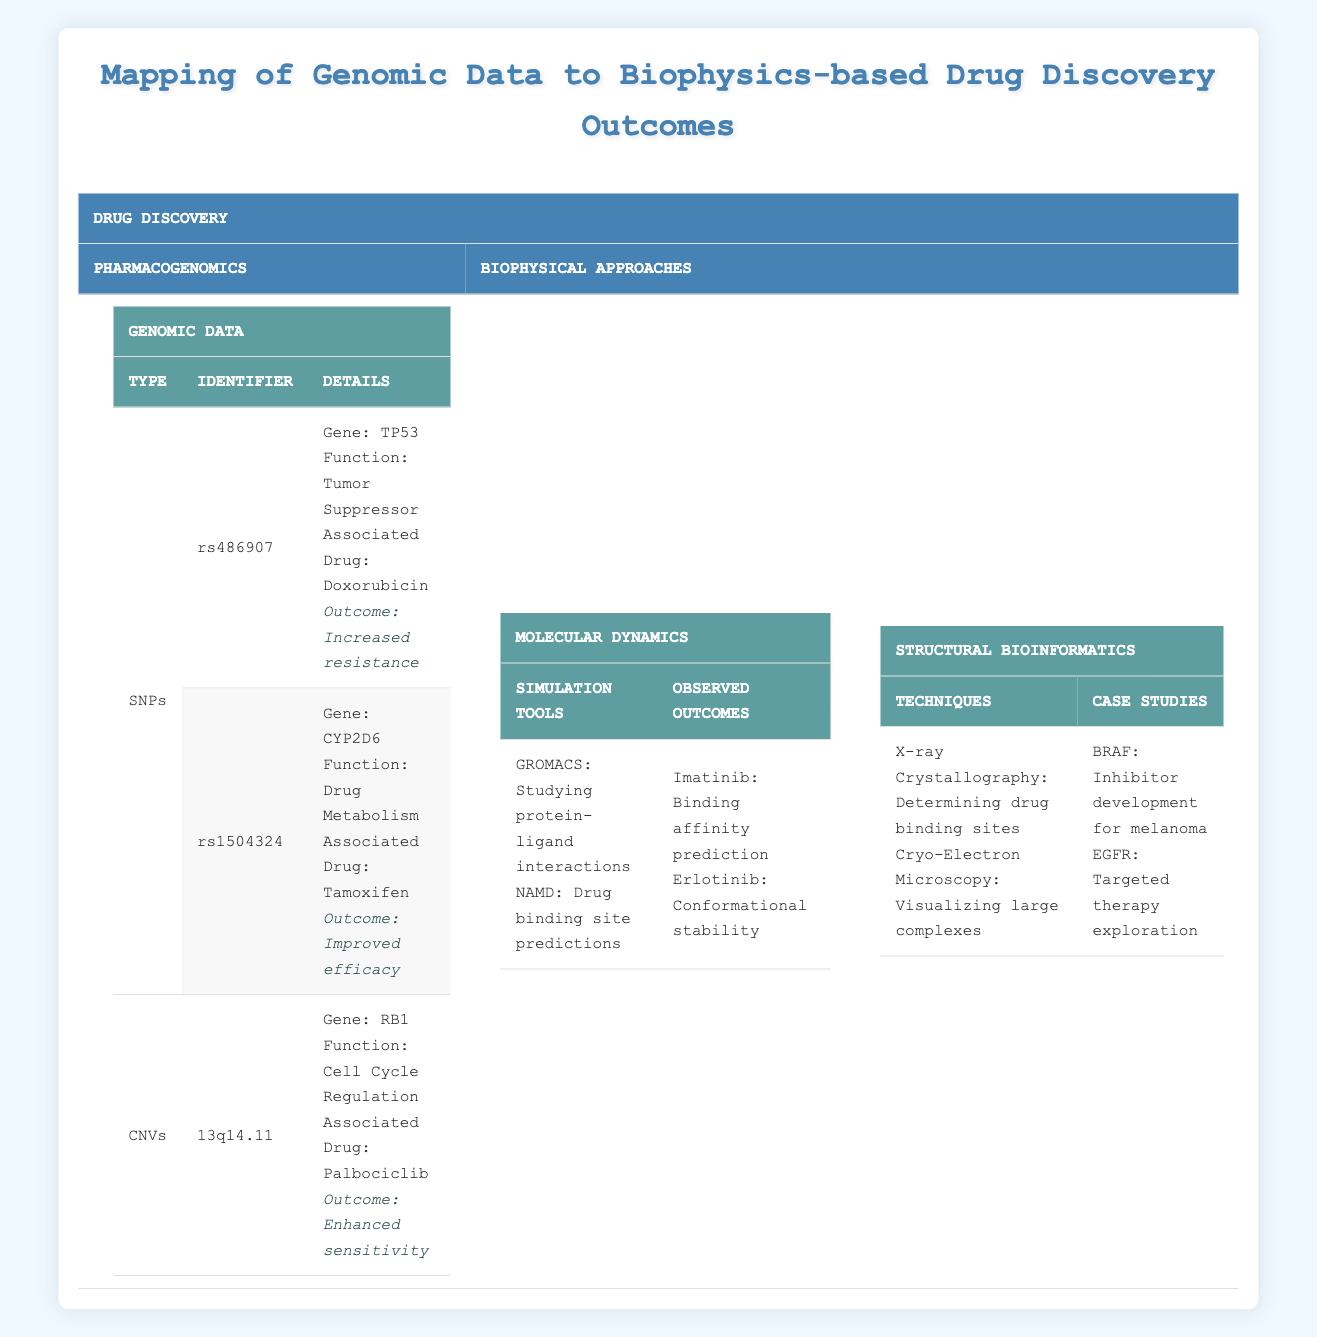What gene is associated with the SNP rs486907? From the table under the SNPs section, the SNP rs486907 is linked to the gene TP53.
Answer: TP53 What is the drug outcome associated with rs1504324? The table states that the SNP rs1504324, which is linked to the gene CYP2D6 and associated with the drug Tamoxifen, has an outcome of improved efficacy.
Answer: Improved efficacy Is there a drug listed for the CNV 13q14.11? According to the table, the CNV 13q14.11 is associated with the gene RB1 and the drug Palbociclib, indicating that there is indeed a listed drug.
Answer: Yes Which drug outcomes are listed for biophysics approaches? The table shows that for molecular dynamics, Imatinib has a predicted binding affinity outcome, and Erlotinib shows conformational stability.
Answer: Imatinib and Erlotinib Which technique is used for determining drug binding sites? The table indicates that X-ray Crystallography is used for determining drug binding sites in the structural bioinformatics section.
Answer: X-ray Crystallography How many different simulation tools are mentioned in the table? There are two simulation tools mentioned in the molecular dynamics part: GROMACS and NAMD, so the total is 2.
Answer: 2 What is the outcome associated with the protein EGFR? The case study associated with the protein EGFR indicates it relates to targeted therapy exploration.
Answer: Targeted therapy exploration Which drug shows enhanced sensitivity according to the data? The table specifies that the drug Palbociclib is associated with enhanced sensitivity through the CNV 13q14.11 linked to RB1.
Answer: Palbociclib Which drug can be linked to tumor suppressor TP53 based on the genomic data? The SNP rs486907 is linked to the tumor suppressor gene TP53, and the associated drug listed is Doxorubicin.
Answer: Doxorubicin How many drug outcomes relate to the listed drugs under pharmacogenomics? The table lists three outcomes for three drugs under pharmacogenomics: Doxorubicin, Tamoxifen, and Palbociclib, giving a total of 3 outcomes.
Answer: 3 